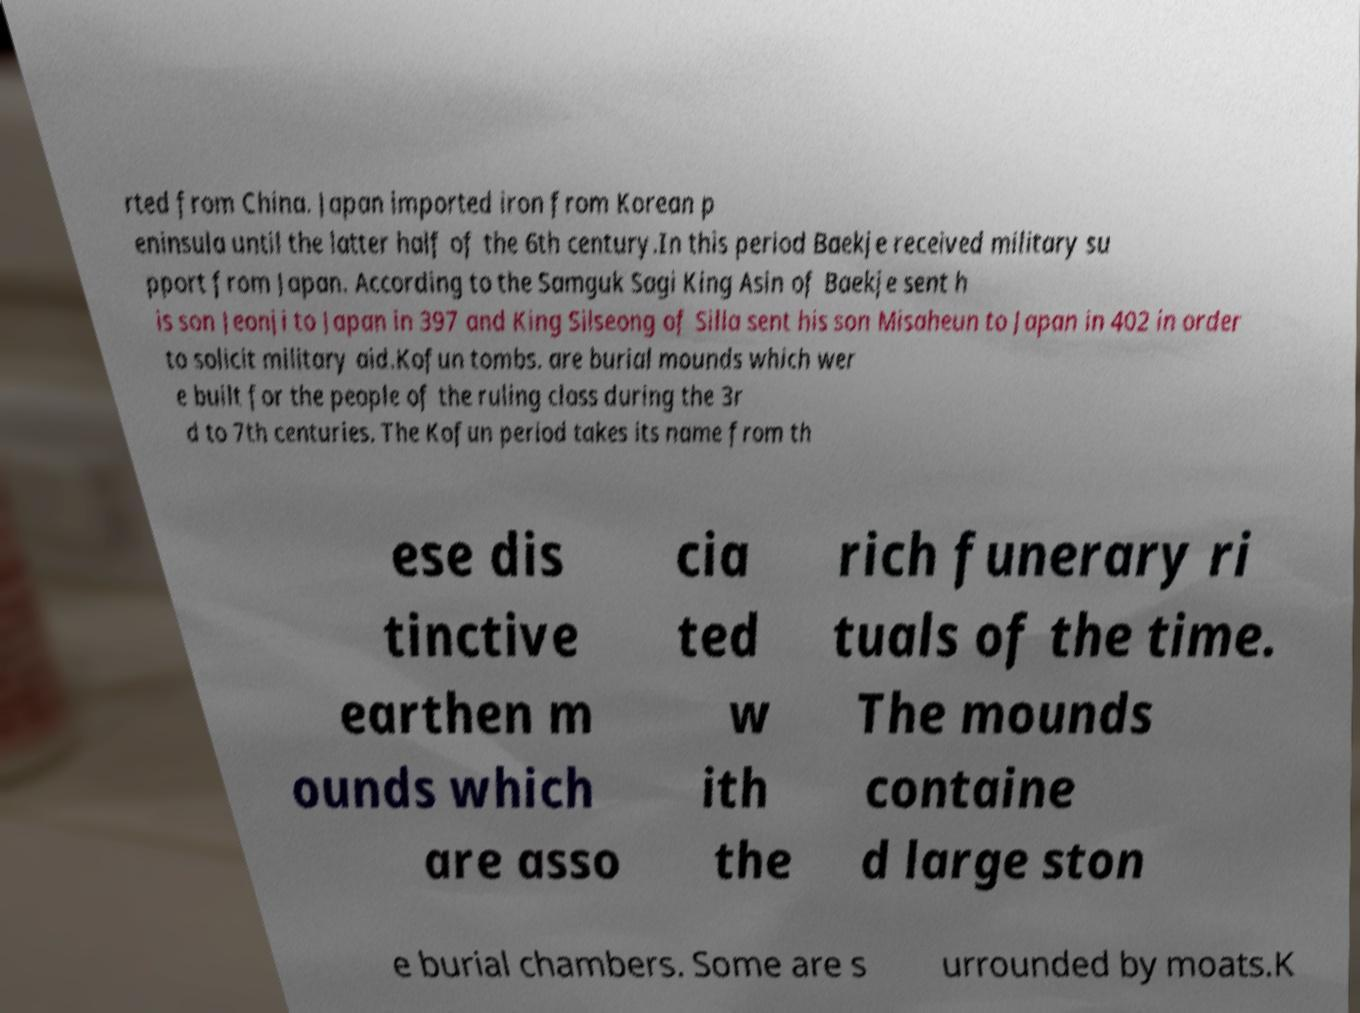There's text embedded in this image that I need extracted. Can you transcribe it verbatim? rted from China. Japan imported iron from Korean p eninsula until the latter half of the 6th century.In this period Baekje received military su pport from Japan. According to the Samguk Sagi King Asin of Baekje sent h is son Jeonji to Japan in 397 and King Silseong of Silla sent his son Misaheun to Japan in 402 in order to solicit military aid.Kofun tombs. are burial mounds which wer e built for the people of the ruling class during the 3r d to 7th centuries. The Kofun period takes its name from th ese dis tinctive earthen m ounds which are asso cia ted w ith the rich funerary ri tuals of the time. The mounds containe d large ston e burial chambers. Some are s urrounded by moats.K 